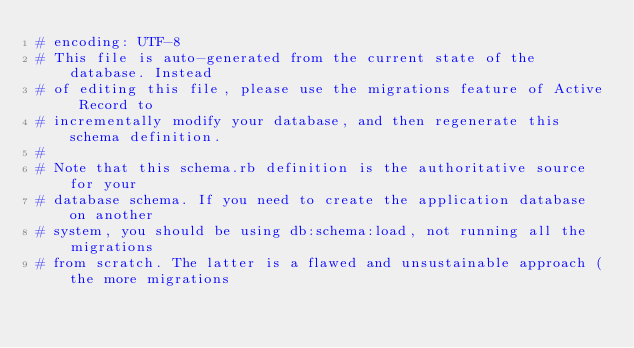<code> <loc_0><loc_0><loc_500><loc_500><_Ruby_># encoding: UTF-8
# This file is auto-generated from the current state of the database. Instead
# of editing this file, please use the migrations feature of Active Record to
# incrementally modify your database, and then regenerate this schema definition.
#
# Note that this schema.rb definition is the authoritative source for your
# database schema. If you need to create the application database on another
# system, you should be using db:schema:load, not running all the migrations
# from scratch. The latter is a flawed and unsustainable approach (the more migrations</code> 